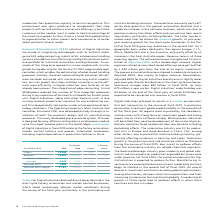According to Siemens Ag's financial document, What was the rationale for decline in the orders for digital industries? due to lower demand in the short-cycle factory automation and motion control businesses, which faced increasingly adverse market conditions during the course of the fiscal year, particularly in the automotive and machine building industries.. The document states: "Orders for Digital Industries declined due to lower demand in the short-cycle factory automation and motion control businesses, which faced increasing..." Also, What was the severance charge in 2019? Severance charges were € 92 million in fiscal 2019. The document states: "to clear declines in the short-cycle businesses. Severance charges were € 92 million in fiscal 2019, up from € 75 million a year earlier. Digital Indu..." Also, What was the impact of positive development of raw material prices on discrete industries? discrete industries faced headwinds from low demand including destocking effects. The document states: "from positive development of raw material prices, discrete industries faced headwinds from low demand including destocking effects. The automotive ind..." Also, can you calculate: What was the average revenue in 2019 and 2018? To answer this question, I need to perform calculations using the financial data. The calculation is: (16,087 + 15,587) / 2, which equals 15837 (in millions). This is based on the information: "Revenue 16,087 15,587 3 % 2 % Revenue 16,087 15,587 3 % 2 %..." The key data points involved are: 15,587, 16,087. Also, can you calculate: What is the increase / (decrease) in the Adjusted EBITDA margin from 2018 to 2019? Based on the calculation: 17.9% - 18.6%, the result is -0.7 (percentage). This is based on the information: "Adjusted EBITA margin 17.9 % 18.6 % Adjusted EBITA margin 17.9 % 18.6 %..." The key data points involved are: 17.9, 18.6. Also, can you calculate: What percentage of revenue is software business comprised of in 2019? Based on the calculation: 4,039 / 16,087, the result is 25.11 (percentage). This is based on the information: "therein: software business 4,039 3,560 13 % 8 % Revenue 16,087 15,587 3 % 2 %..." The key data points involved are: 16,087, 4,039. 